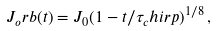Convert formula to latex. <formula><loc_0><loc_0><loc_500><loc_500>J _ { o } r b ( t ) = J _ { 0 } ( 1 - t / \tau _ { c } h i r p ) ^ { 1 / 8 } \, ,</formula> 